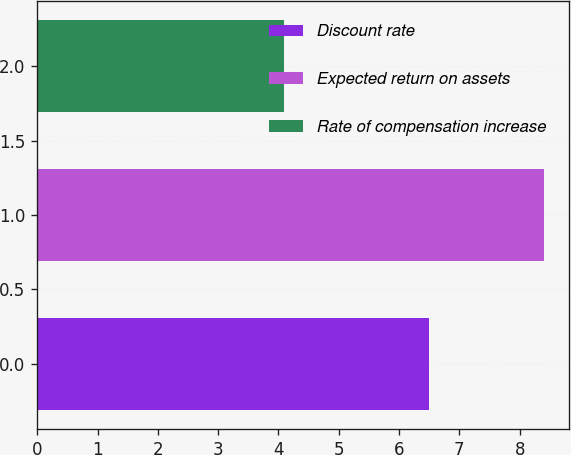Convert chart. <chart><loc_0><loc_0><loc_500><loc_500><bar_chart><fcel>Discount rate<fcel>Expected return on assets<fcel>Rate of compensation increase<nl><fcel>6.5<fcel>8.4<fcel>4.1<nl></chart> 